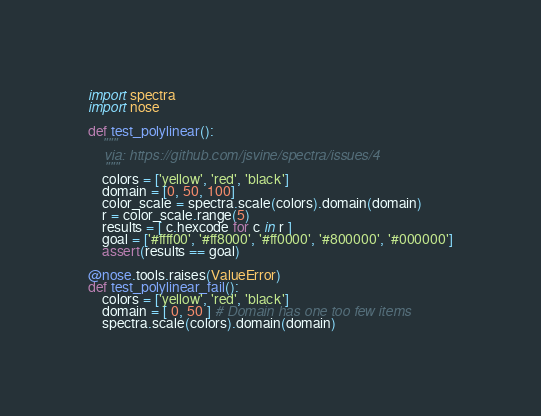Convert code to text. <code><loc_0><loc_0><loc_500><loc_500><_Python_>import spectra
import nose

def test_polylinear():
    """
    via: https://github.com/jsvine/spectra/issues/4
    """
    colors = ['yellow', 'red', 'black']
    domain = [0, 50, 100]
    color_scale = spectra.scale(colors).domain(domain)
    r = color_scale.range(5)
    results = [ c.hexcode for c in r ]
    goal = ['#ffff00', '#ff8000', '#ff0000', '#800000', '#000000']
    assert(results == goal)

@nose.tools.raises(ValueError)
def test_polylinear_fail():
    colors = ['yellow', 'red', 'black']
    domain = [ 0, 50 ] # Domain has one too few items
    spectra.scale(colors).domain(domain)
</code> 